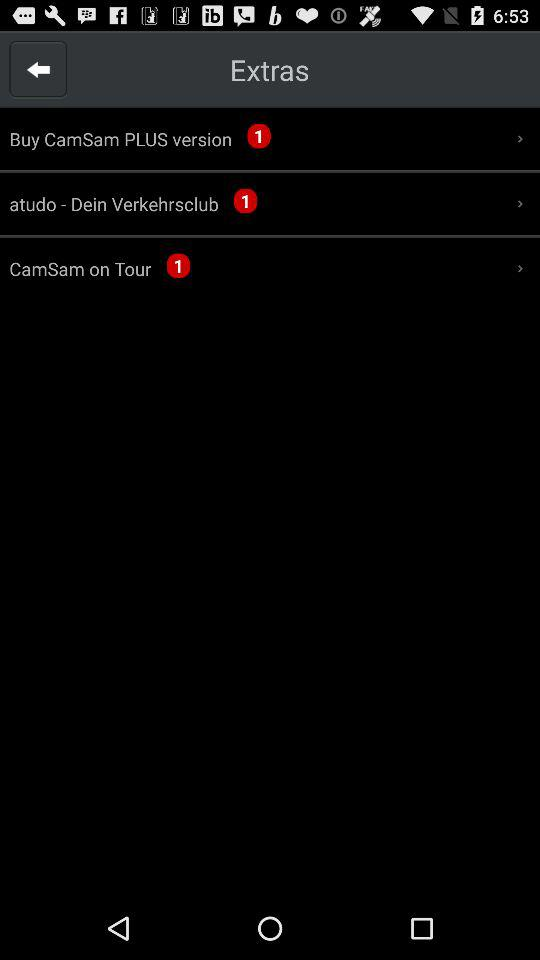How many new notifications are there for the Buy CamSam PLUS version? There is 1 notification for the Buy CamSam PLUS version. 